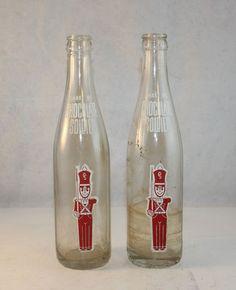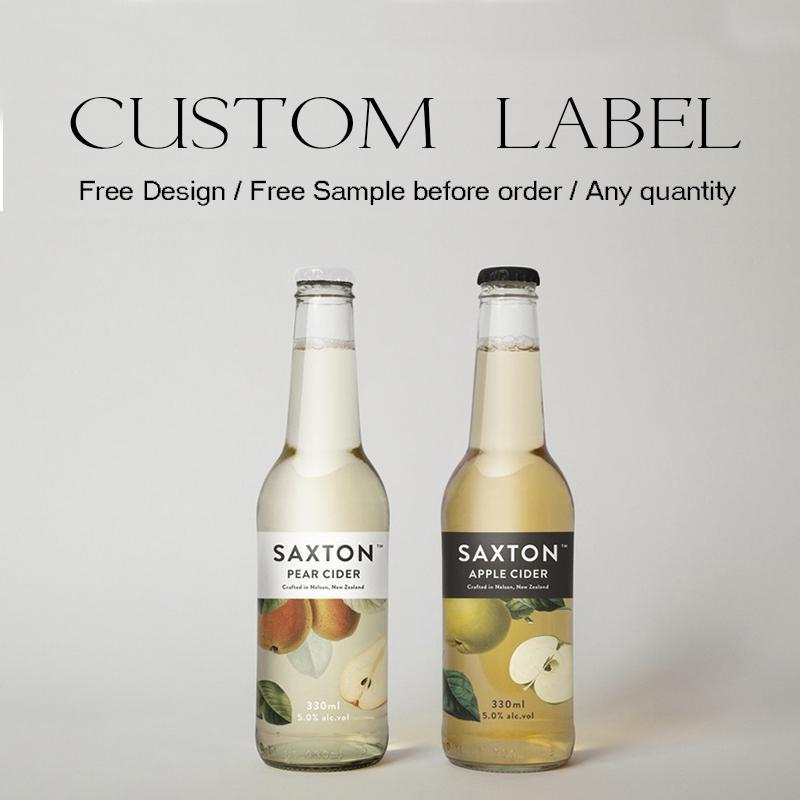The first image is the image on the left, the second image is the image on the right. Given the left and right images, does the statement "Each image contains three empty glass soda bottles, and at least one image features bottles with orange labels facing forward." hold true? Answer yes or no. No. The first image is the image on the left, the second image is the image on the right. Considering the images on both sides, is "There are fewer than six bottles in total." valid? Answer yes or no. Yes. 